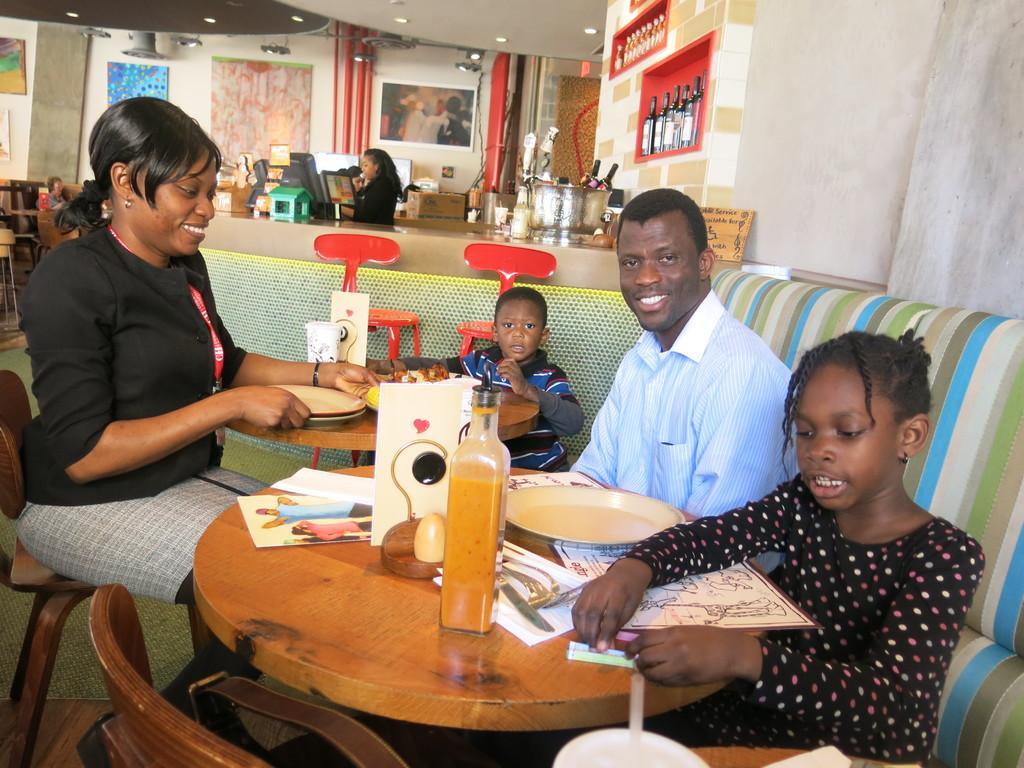Describe this image in one or two sentences. There are four members in the given picture. Two of them were children. Two of them were adults. All of them were sitting around two tables. In the background there is a woman standing in front of a monitor. We can have some pipes, photographs and the curtain here. 